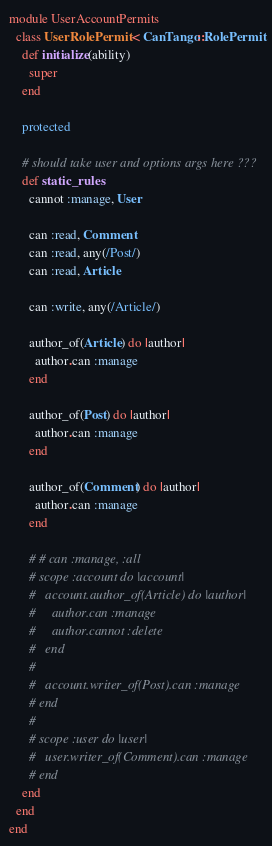<code> <loc_0><loc_0><loc_500><loc_500><_Ruby_>module UserAccountPermits
  class UserRolePermit < CanTango::RolePermit
    def initialize(ability)
      super
    end

    protected

    # should take user and options args here ???
    def static_rules
      cannot :manage, User

      can :read, Comment
      can :read, any(/Post/)
      can :read, Article

      can :write, any(/Article/)

      author_of(Article) do |author|
        author.can :manage
      end

      author_of(Post) do |author|
        author.can :manage
      end

      author_of(Comment) do |author|
        author.can :manage
      end

      # # can :manage, :all    
      # scope :account do |account|
      #   account.author_of(Article) do |author|
      #     author.can :manage
      #     author.cannot :delete
      #   end          
      #     
      #   account.writer_of(Post).can :manage
      # end
      # 
      # scope :user do |user|      
      #   user.writer_of(Comment).can :manage
      # end
    end  
  end
end
</code> 